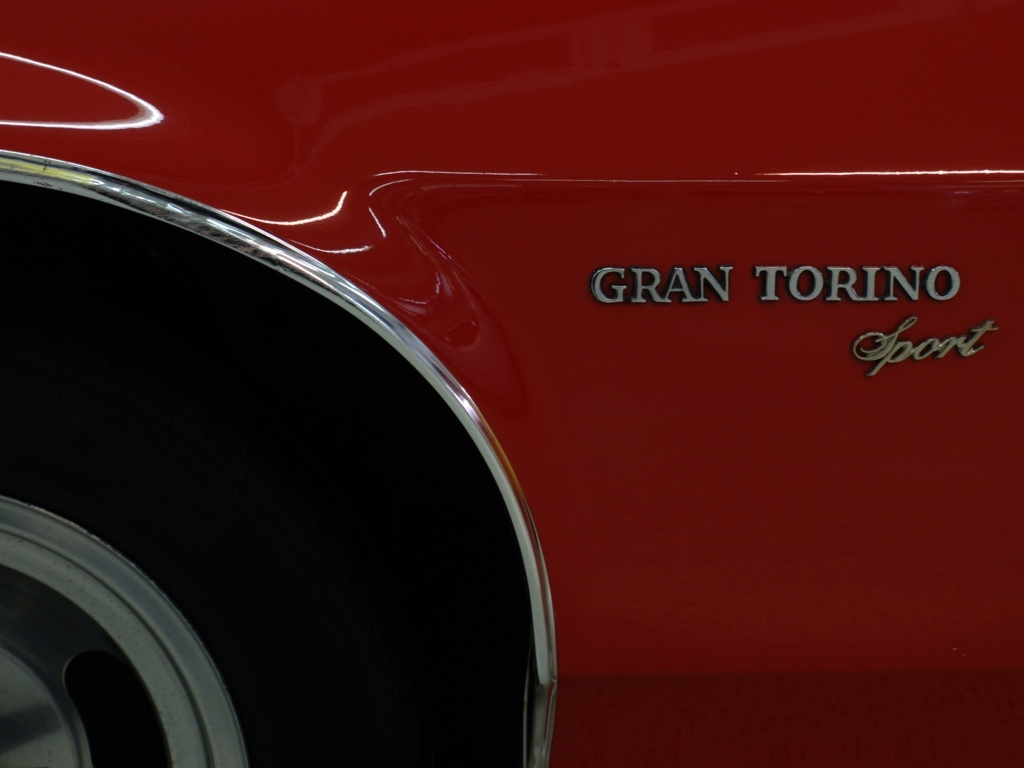Can you tell me the make and model of the car shown? The image depicts a vehicle side panel with the inscription 'GRAN TORINO Sport,' which indicates that this is likely a model of the Ford Gran Torino, a popular car from the mid-20th century. The exact year of the model cannot be determined from this detail alone. 